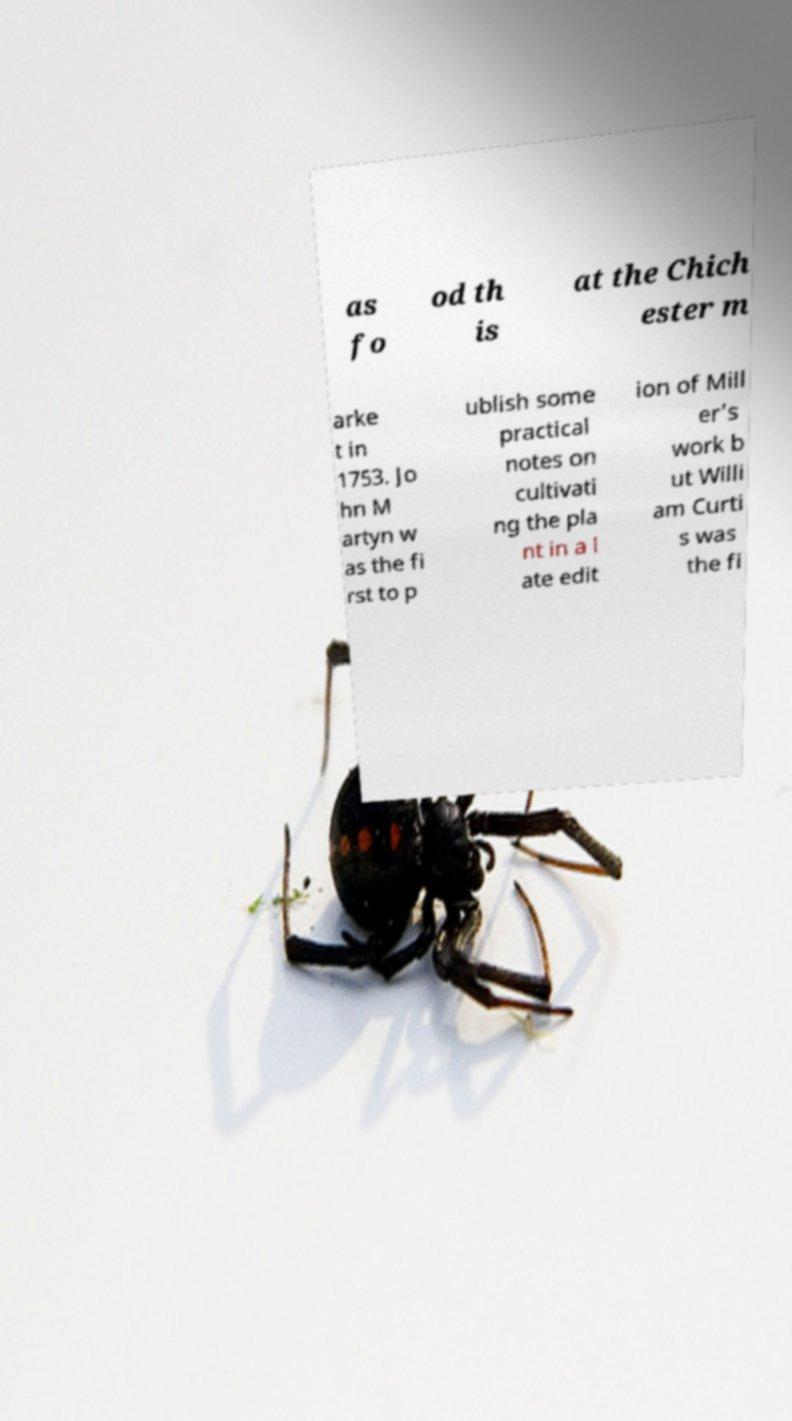There's text embedded in this image that I need extracted. Can you transcribe it verbatim? as fo od th is at the Chich ester m arke t in 1753. Jo hn M artyn w as the fi rst to p ublish some practical notes on cultivati ng the pla nt in a l ate edit ion of Mill er's work b ut Willi am Curti s was the fi 